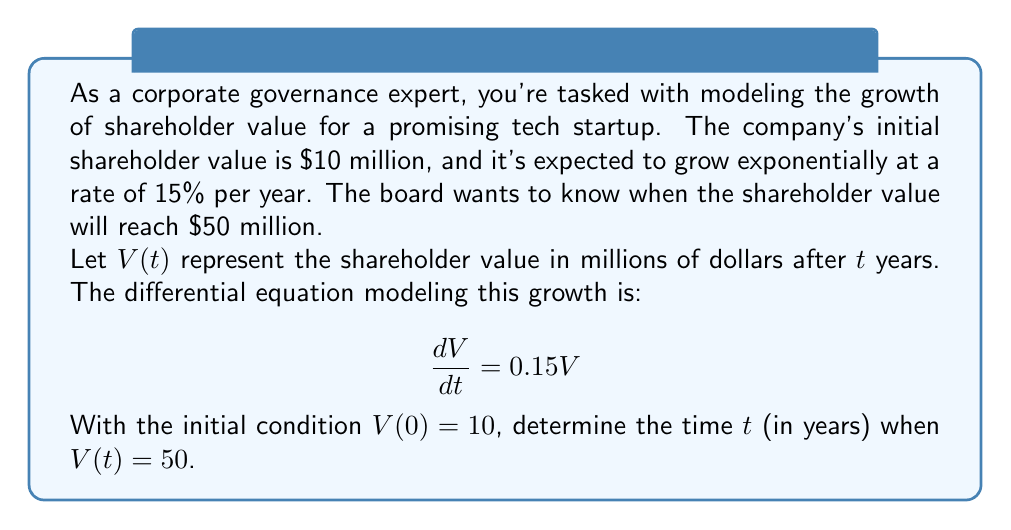What is the answer to this math problem? Let's solve this step-by-step:

1) We start with the differential equation:
   $$\frac{dV}{dt} = 0.15V$$

2) This is a separable equation. We can rewrite it as:
   $$\frac{dV}{V} = 0.15dt$$

3) Integrating both sides:
   $$\int \frac{dV}{V} = \int 0.15dt$$
   $$\ln|V| = 0.15t + C$$

4) Using the initial condition $V(0) = 10$, we can find $C$:
   $$\ln(10) = 0.15(0) + C$$
   $$C = \ln(10)$$

5) So our general solution is:
   $$\ln|V| = 0.15t + \ln(10)$$

6) Simplifying:
   $$V = 10e^{0.15t}$$

7) Now, we want to find $t$ when $V = 50$:
   $$50 = 10e^{0.15t}$$

8) Dividing both sides by 10:
   $$5 = e^{0.15t}$$

9) Taking the natural log of both sides:
   $$\ln(5) = 0.15t$$

10) Solving for $t$:
    $$t = \frac{\ln(5)}{0.15} \approx 10.75$$

Therefore, it will take approximately 10.75 years for the shareholder value to reach $50 million.
Answer: $10.75$ years 